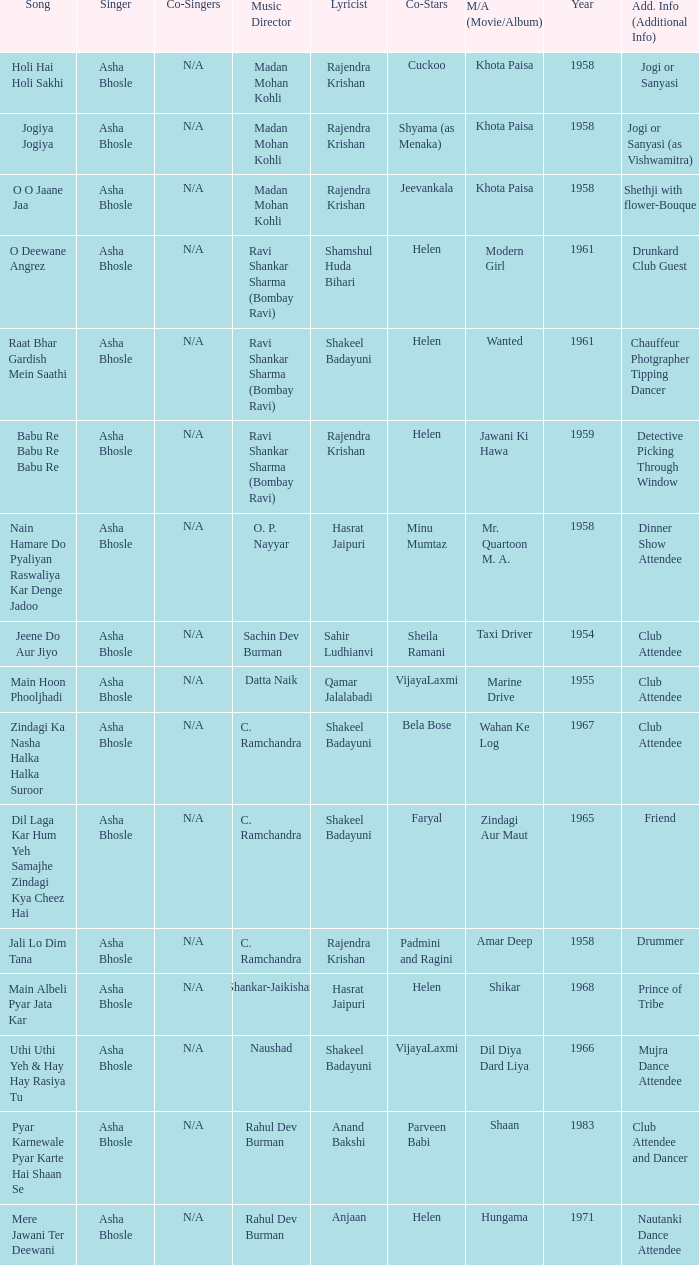How many co-singers were there when Parveen Babi co-starred? 1.0. 